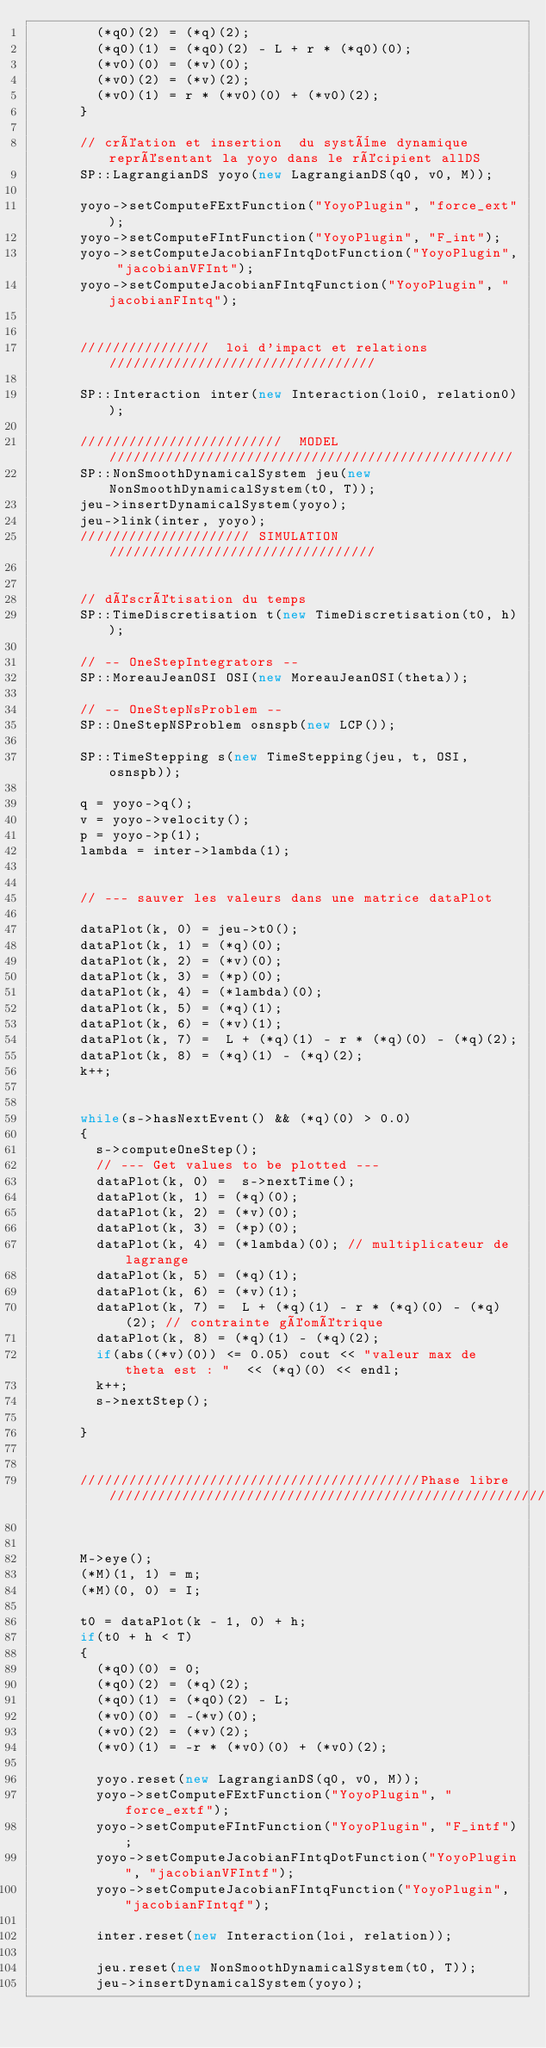Convert code to text. <code><loc_0><loc_0><loc_500><loc_500><_C++_>        (*q0)(2) = (*q)(2);
        (*q0)(1) = (*q0)(2) - L + r * (*q0)(0);
        (*v0)(0) = (*v)(0);
        (*v0)(2) = (*v)(2);
        (*v0)(1) = r * (*v0)(0) + (*v0)(2);
      }

      // création et insertion  du système dynamique représentant la yoyo dans le récipient allDS
      SP::LagrangianDS yoyo(new LagrangianDS(q0, v0, M));

      yoyo->setComputeFExtFunction("YoyoPlugin", "force_ext");
      yoyo->setComputeFIntFunction("YoyoPlugin", "F_int");
      yoyo->setComputeJacobianFIntqDotFunction("YoyoPlugin", "jacobianVFInt");
      yoyo->setComputeJacobianFIntqFunction("YoyoPlugin", "jacobianFIntq");


      ////////////////  loi d'impact et relations /////////////////////////////////

      SP::Interaction inter(new Interaction(loi0, relation0));

      /////////////////////////  MODEL //////////////////////////////////////////////////
      SP::NonSmoothDynamicalSystem jeu(new NonSmoothDynamicalSystem(t0, T));
      jeu->insertDynamicalSystem(yoyo);
      jeu->link(inter, yoyo);
      ///////////////////// SIMULATION /////////////////////////////////


      // déscrétisation du temps
      SP::TimeDiscretisation t(new TimeDiscretisation(t0, h));

      // -- OneStepIntegrators --
      SP::MoreauJeanOSI OSI(new MoreauJeanOSI(theta));

      // -- OneStepNsProblem --
      SP::OneStepNSProblem osnspb(new LCP());

      SP::TimeStepping s(new TimeStepping(jeu, t, OSI, osnspb));

      q = yoyo->q();
      v = yoyo->velocity();
      p = yoyo->p(1);
      lambda = inter->lambda(1);


      // --- sauver les valeurs dans une matrice dataPlot

      dataPlot(k, 0) = jeu->t0();
      dataPlot(k, 1) = (*q)(0);
      dataPlot(k, 2) = (*v)(0);
      dataPlot(k, 3) = (*p)(0);
      dataPlot(k, 4) = (*lambda)(0);
      dataPlot(k, 5) = (*q)(1);
      dataPlot(k, 6) = (*v)(1);
      dataPlot(k, 7) =  L + (*q)(1) - r * (*q)(0) - (*q)(2);
      dataPlot(k, 8) = (*q)(1) - (*q)(2);
      k++;


      while(s->hasNextEvent() && (*q)(0) > 0.0)
      {
        s->computeOneStep();
        // --- Get values to be plotted ---
        dataPlot(k, 0) =  s->nextTime();
        dataPlot(k, 1) = (*q)(0);
        dataPlot(k, 2) = (*v)(0);
        dataPlot(k, 3) = (*p)(0);
        dataPlot(k, 4) = (*lambda)(0); // multiplicateur de lagrange
        dataPlot(k, 5) = (*q)(1);
        dataPlot(k, 6) = (*v)(1);
        dataPlot(k, 7) =  L + (*q)(1) - r * (*q)(0) - (*q)(2); // contrainte géométrique
        dataPlot(k, 8) = (*q)(1) - (*q)(2);
        if(abs((*v)(0)) <= 0.05) cout << "valeur max de theta est : "  << (*q)(0) << endl;
        k++;
        s->nextStep();

      }


      //////////////////////////////////////////Phase libre//////////////////////////////////////////////////////


      M->eye();
      (*M)(1, 1) = m;
      (*M)(0, 0) = I;

      t0 = dataPlot(k - 1, 0) + h;
      if(t0 + h < T)
      {
        (*q0)(0) = 0;
        (*q0)(2) = (*q)(2);
        (*q0)(1) = (*q0)(2) - L;
        (*v0)(0) = -(*v)(0);
        (*v0)(2) = (*v)(2);
        (*v0)(1) = -r * (*v0)(0) + (*v0)(2);

        yoyo.reset(new LagrangianDS(q0, v0, M));
        yoyo->setComputeFExtFunction("YoyoPlugin", "force_extf");
        yoyo->setComputeFIntFunction("YoyoPlugin", "F_intf");
        yoyo->setComputeJacobianFIntqDotFunction("YoyoPlugin", "jacobianVFIntf");
        yoyo->setComputeJacobianFIntqFunction("YoyoPlugin", "jacobianFIntqf");

        inter.reset(new Interaction(loi, relation));

        jeu.reset(new NonSmoothDynamicalSystem(t0, T));
        jeu->insertDynamicalSystem(yoyo);</code> 